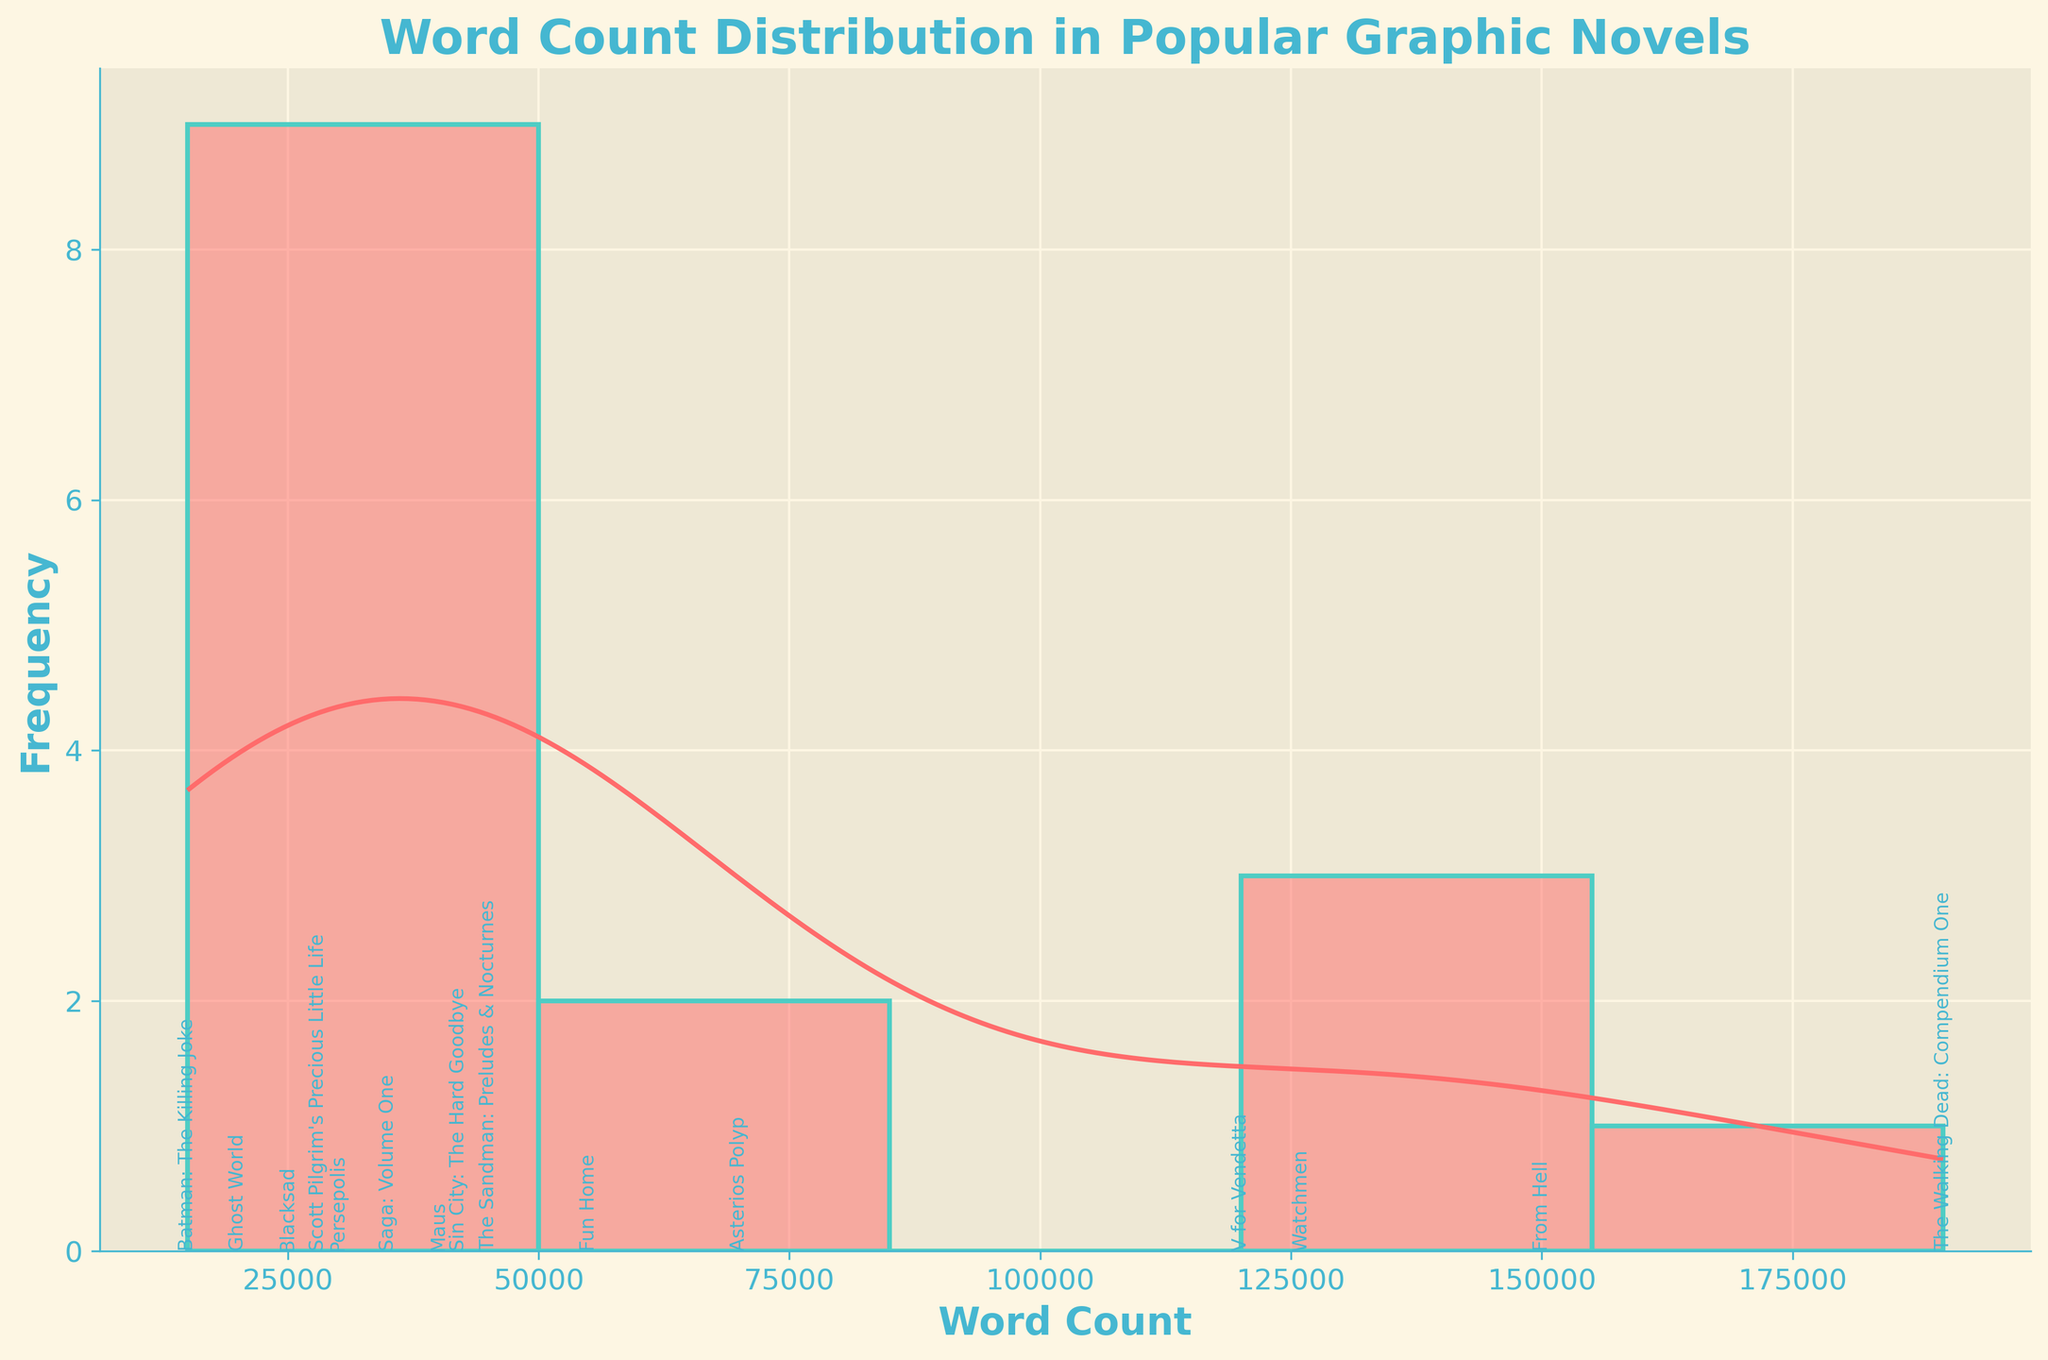What is the title of the histogram? The title is written at the top of the histogram in a larger, bold font. It provides a summary of what the histogram is about.
Answer: Word Count Distribution in Popular Graphic Novels How many graphic novels have word counts between 100,000 and 150,000? By observing the x-axis and the corresponding histogram bars, we identify the number of novels within the specified range and count the respective annotations.
Answer: 3 Which graphic novel has the highest word count? Look for the bar with the highest word count on the x-axis and read the annotation above it.
Answer: The Walking Dead: Compendium One Which graphic novel has the lowest word count? Look for the bar with the lowest word count on the x-axis and read the annotation above it.
Answer: Batman: The Killing Joke What is the approximate range of word counts displayed in the histogram? Examine the x-axis for the minimum and maximum values of word counts shown in the histogram.
Answer: 15,000 to 190,000 Is there a graphic novel in the histogram with a word count exactly at 50,000? Check the x-axis for the position of 50,000 and see if there is a corresponding bar and annotation.
Answer: No What can you say about the distribution of word counts in graphic novels based on the density curve (KDE)? Look at the shape of the density curve to understand how word counts are distributed. The peaks indicate where word counts are most concentrated, and the spread shows the range.
Answer: Bimodal distribution with peaks around 20,000 and 120,000 How many graphic novels have word counts below 50,000? Identify the histogram bars to the left of 50,000 on the x-axis and count the respective annotations.
Answer: 6 Which graphic novel falls closest to the median word count displayed? Approximate the median by locating the middle value on the x-axis, then identify the graphic novel closest to this value from the bars and annotations.
Answer: Sin City: The Hard Goodbye Compare the word count of From Hell and Maus. Which one is higher and by how much? Find the positions of "From Hell" and "Maus" on the x-axis, read their word counts, and subtract Maus's word count from From Hell’s word count.
Answer: From Hell is higher by 110,000 words What is the color of the histogram bars? Observe and describe the color of the bars used in the histogram.
Answer: Light red (with teal edges) 